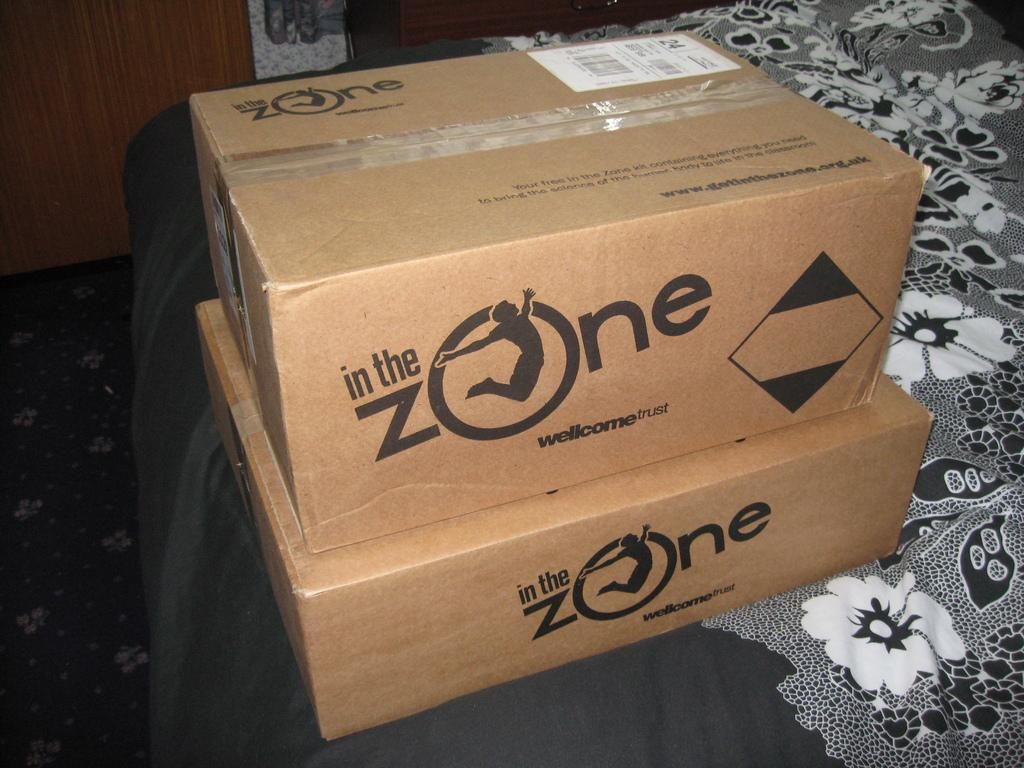<image>
Provide a brief description of the given image. A stack of packages with in the Zone on the side of the box. 